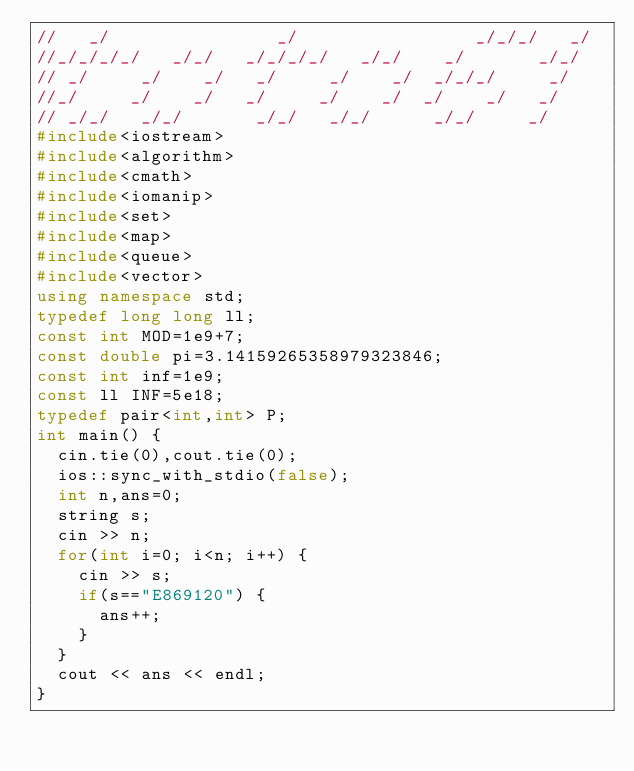<code> <loc_0><loc_0><loc_500><loc_500><_C++_>//   _/                _/                 _/_/_/   _/
//_/_/_/_/   _/_/   _/_/_/_/   _/_/    _/       _/_/
// _/     _/    _/   _/     _/    _/  _/_/_/     _/
//_/     _/    _/   _/     _/    _/  _/    _/   _/
// _/_/   _/_/       _/_/   _/_/      _/_/     _/
#include<iostream>
#include<algorithm>
#include<cmath>
#include<iomanip>
#include<set>
#include<map>
#include<queue>
#include<vector>
using namespace std;
typedef long long ll;
const int MOD=1e9+7;
const double pi=3.14159265358979323846;
const int inf=1e9;
const ll INF=5e18;
typedef pair<int,int> P;
int main() {
  cin.tie(0),cout.tie(0);
  ios::sync_with_stdio(false);
  int n,ans=0;
  string s;
  cin >> n;
  for(int i=0; i<n; i++) {
    cin >> s;
    if(s=="E869120") {
      ans++;
    }
  }
  cout << ans << endl;
}
</code> 